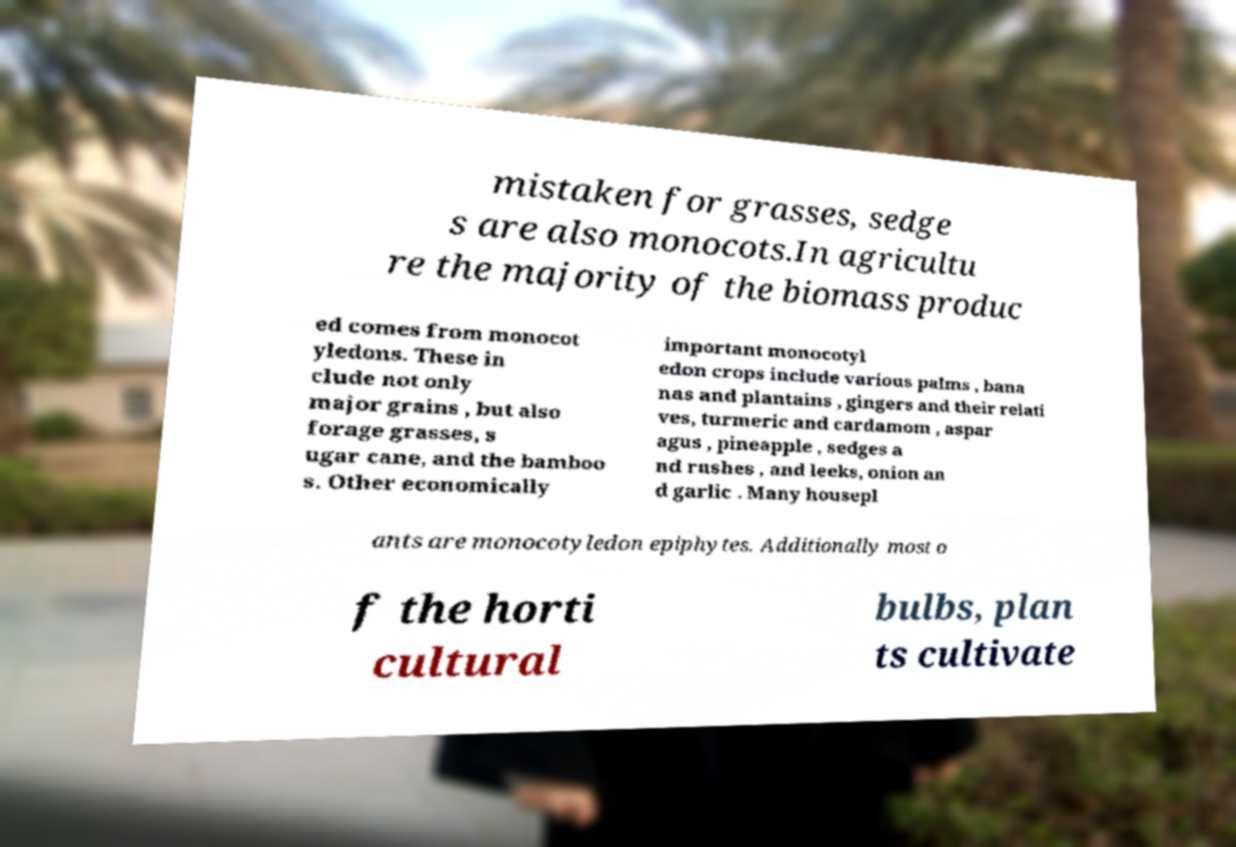Can you read and provide the text displayed in the image?This photo seems to have some interesting text. Can you extract and type it out for me? mistaken for grasses, sedge s are also monocots.In agricultu re the majority of the biomass produc ed comes from monocot yledons. These in clude not only major grains , but also forage grasses, s ugar cane, and the bamboo s. Other economically important monocotyl edon crops include various palms , bana nas and plantains , gingers and their relati ves, turmeric and cardamom , aspar agus , pineapple , sedges a nd rushes , and leeks, onion an d garlic . Many housepl ants are monocotyledon epiphytes. Additionally most o f the horti cultural bulbs, plan ts cultivate 